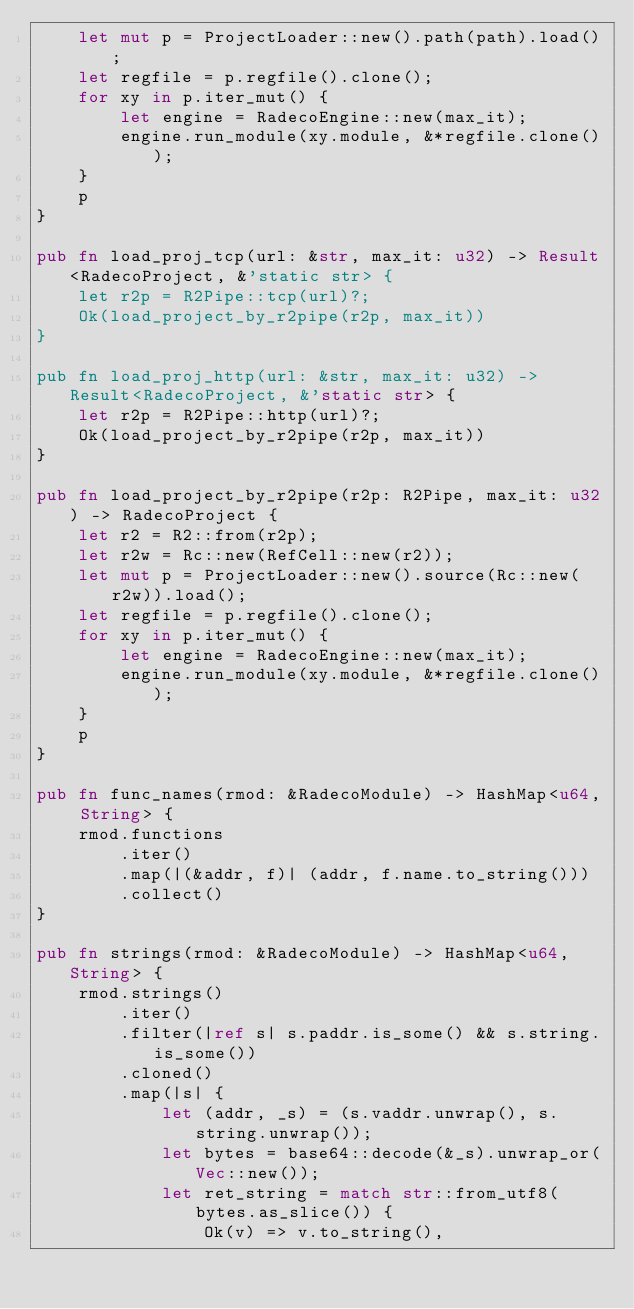Convert code to text. <code><loc_0><loc_0><loc_500><loc_500><_Rust_>    let mut p = ProjectLoader::new().path(path).load();
    let regfile = p.regfile().clone();
    for xy in p.iter_mut() {
        let engine = RadecoEngine::new(max_it);
        engine.run_module(xy.module, &*regfile.clone());
    }
    p
}

pub fn load_proj_tcp(url: &str, max_it: u32) -> Result<RadecoProject, &'static str> {
    let r2p = R2Pipe::tcp(url)?;
    Ok(load_project_by_r2pipe(r2p, max_it))
}

pub fn load_proj_http(url: &str, max_it: u32) -> Result<RadecoProject, &'static str> {
    let r2p = R2Pipe::http(url)?;
    Ok(load_project_by_r2pipe(r2p, max_it))
}

pub fn load_project_by_r2pipe(r2p: R2Pipe, max_it: u32) -> RadecoProject {
    let r2 = R2::from(r2p);
    let r2w = Rc::new(RefCell::new(r2));
    let mut p = ProjectLoader::new().source(Rc::new(r2w)).load();
    let regfile = p.regfile().clone();
    for xy in p.iter_mut() {
        let engine = RadecoEngine::new(max_it);
        engine.run_module(xy.module, &*regfile.clone());
    }
    p
}

pub fn func_names(rmod: &RadecoModule) -> HashMap<u64, String> {
    rmod.functions
        .iter()
        .map(|(&addr, f)| (addr, f.name.to_string()))
        .collect()
}

pub fn strings(rmod: &RadecoModule) -> HashMap<u64, String> {
    rmod.strings()
        .iter()
        .filter(|ref s| s.paddr.is_some() && s.string.is_some())
        .cloned()
        .map(|s| {
            let (addr, _s) = (s.vaddr.unwrap(), s.string.unwrap());
            let bytes = base64::decode(&_s).unwrap_or(Vec::new());
            let ret_string = match str::from_utf8(bytes.as_slice()) {
                Ok(v) => v.to_string(),</code> 